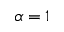<formula> <loc_0><loc_0><loc_500><loc_500>\alpha = 1</formula> 